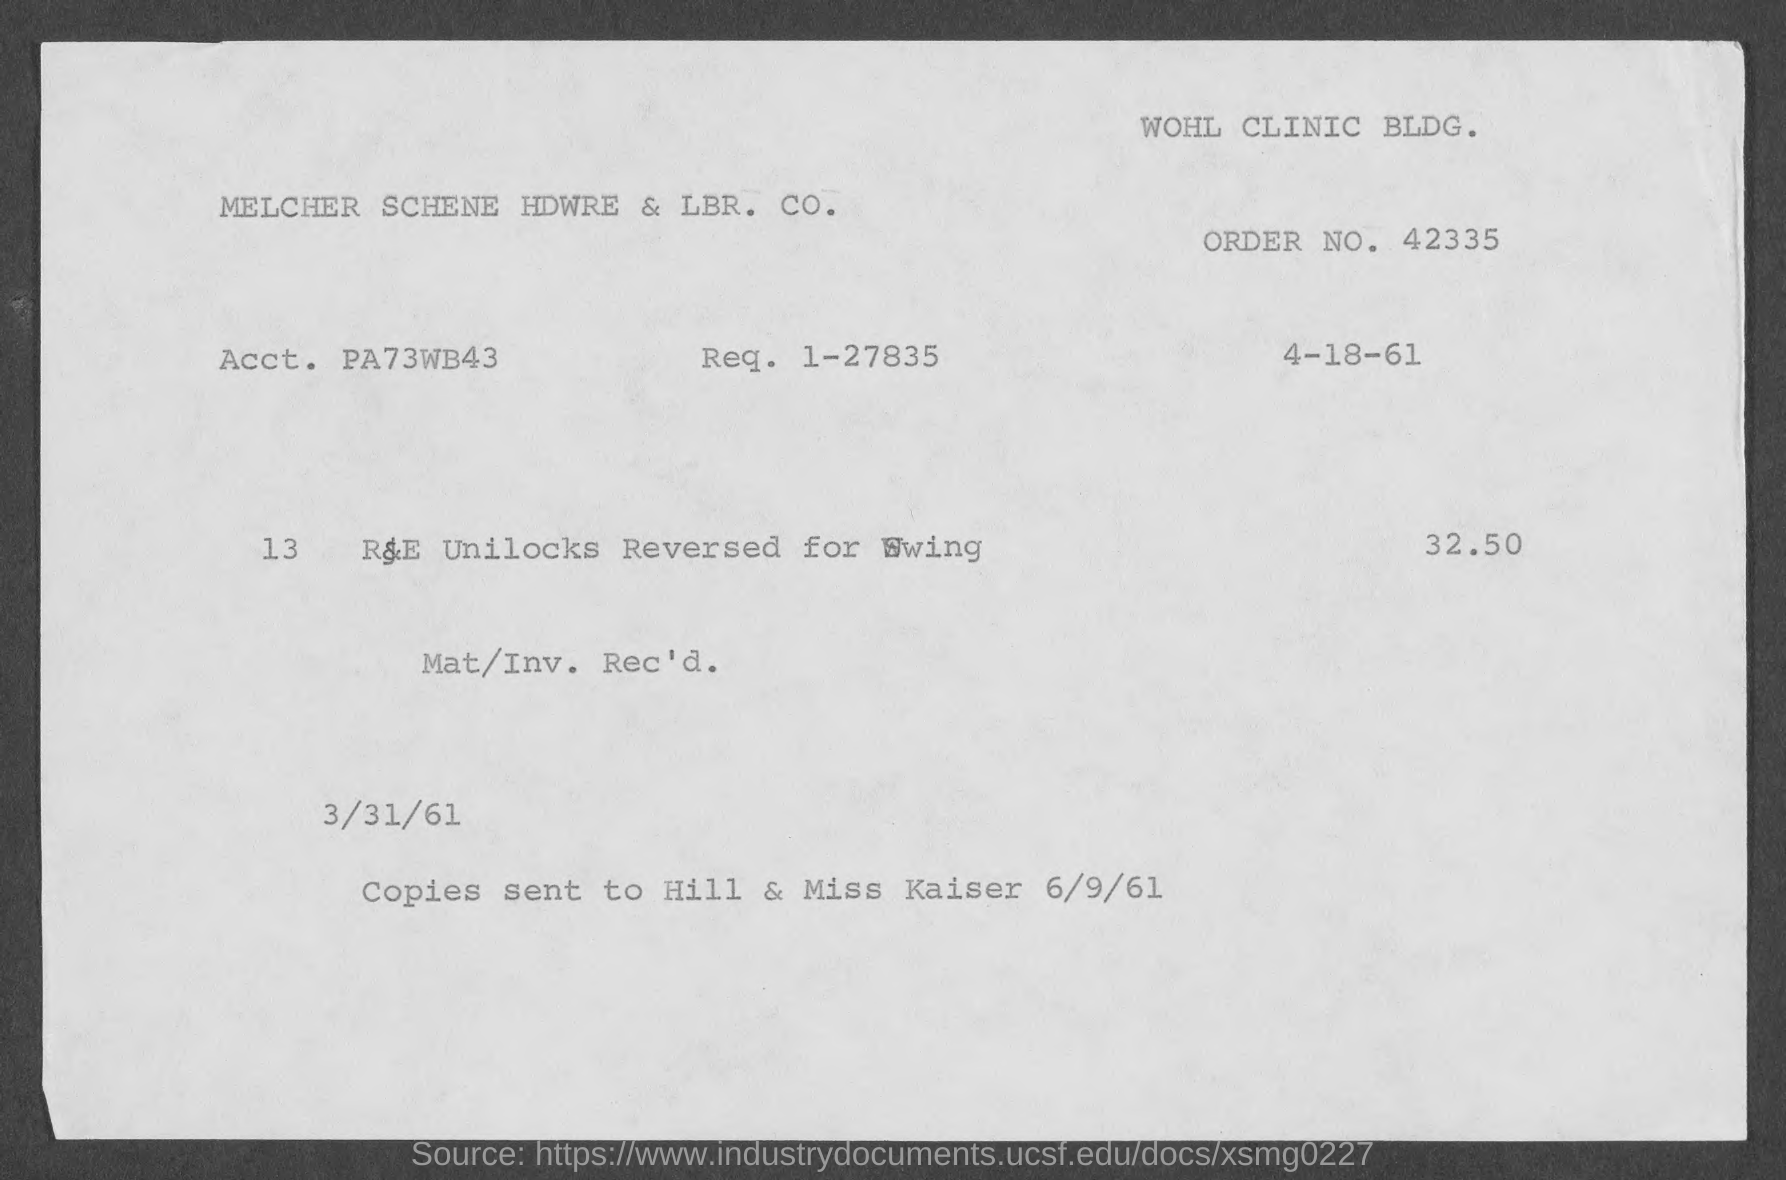Draw attention to some important aspects in this diagram. The request number is 1-27835. The order number is 42335... 